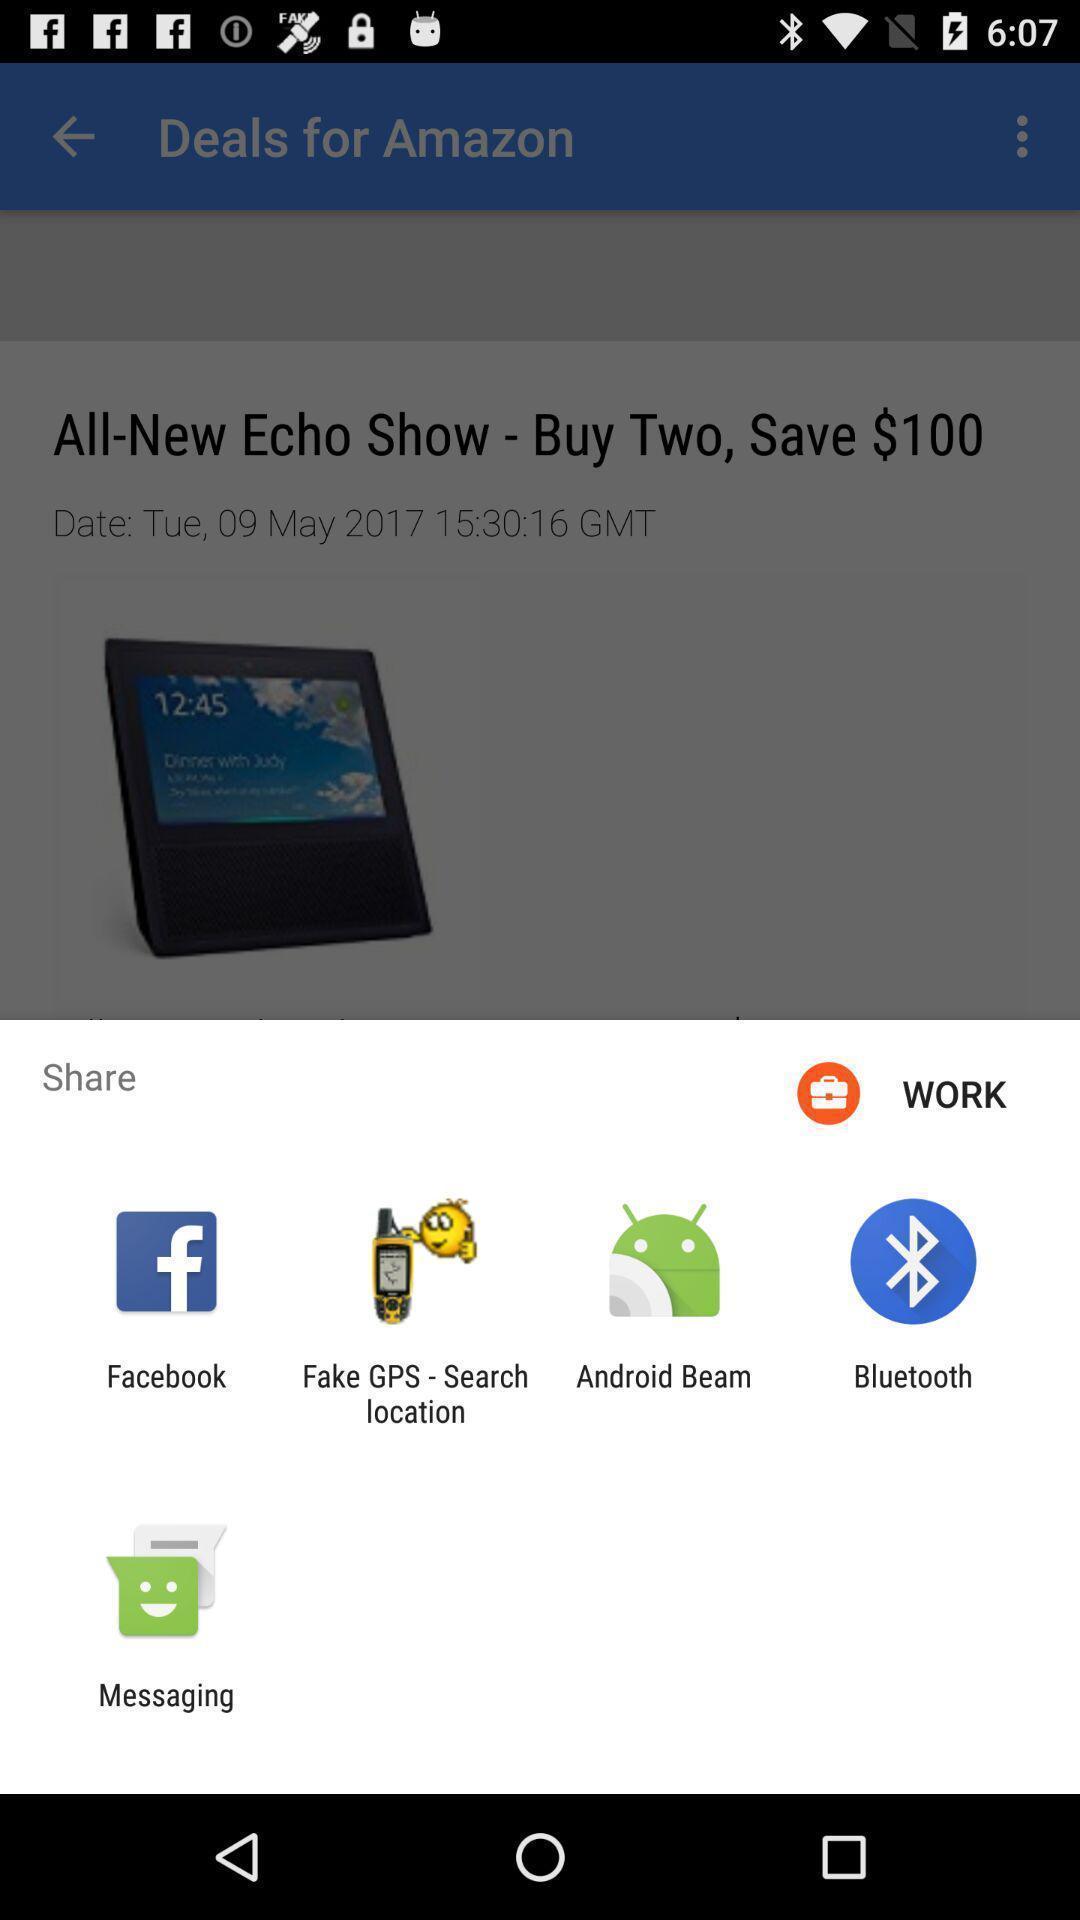Give me a summary of this screen capture. Pop-up shows share option with multiple applications. 